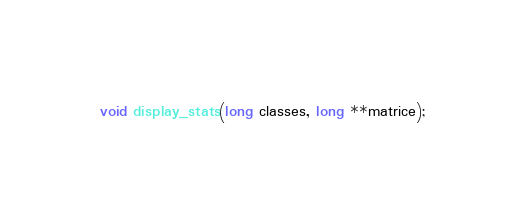<code> <loc_0><loc_0><loc_500><loc_500><_C_>void display_stats(long classes, long **matrice);</code> 